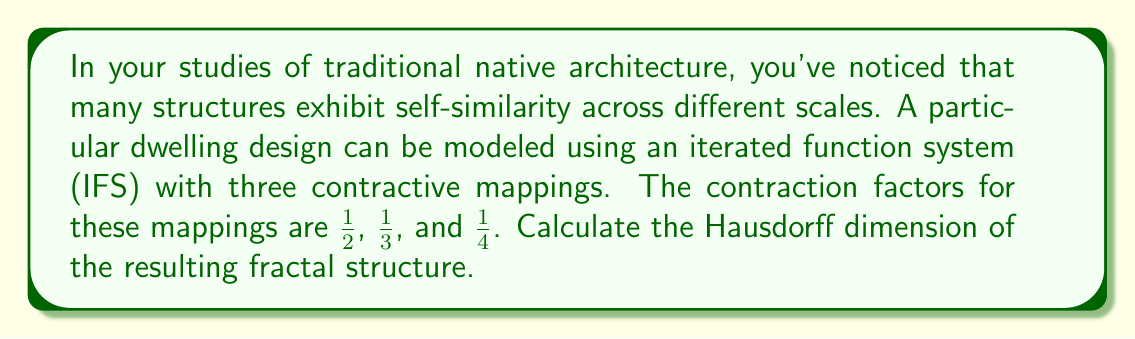Help me with this question. To solve this problem, we'll use the concept of the Hausdorff dimension for self-similar fractals generated by an iterated function system (IFS). The Hausdorff dimension $D$ for such fractals is given by the solution to the equation:

$$\sum_{i=1}^n r_i^D = 1$$

where $r_i$ are the contraction factors of the $n$ mappings in the IFS.

For our problem, we have:

1. $r_1 = \frac{1}{2}$
2. $r_2 = \frac{1}{3}$
3. $r_3 = \frac{1}{4}$

Substituting these into the equation:

$$\left(\frac{1}{2}\right)^D + \left(\frac{1}{3}\right)^D + \left(\frac{1}{4}\right)^D = 1$$

This equation cannot be solved algebraically, so we need to use numerical methods. We can use the bisection method or Newton's method to find the value of $D$ that satisfies this equation.

Using a numerical solver, we find that the solution to this equation is approximately:

$$D \approx 1.2516$$

This value represents the Hausdorff dimension of the fractal structure modeled by the given IFS, which describes the complexity and space-filling properties of the traditional native architecture in question.
Answer: The Hausdorff dimension of the fractal structure is approximately 1.2516. 